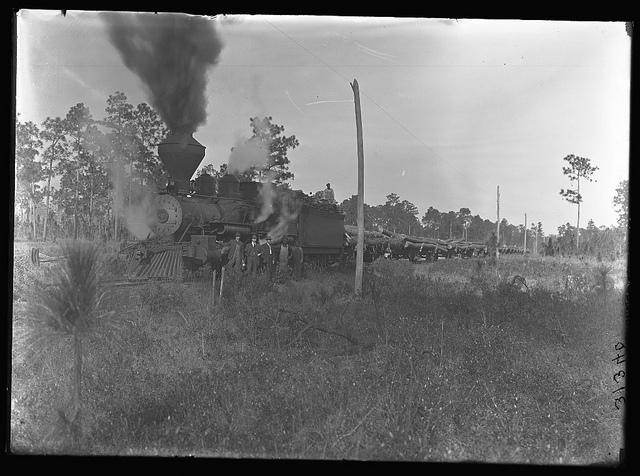What is bellowing from the top of the train?
Give a very brief answer. Smoke. Has the picture been recently taken?
Be succinct. No. What year was this photo taken?
Concise answer only. 1910. Is this a color photograph?
Be succinct. No. 